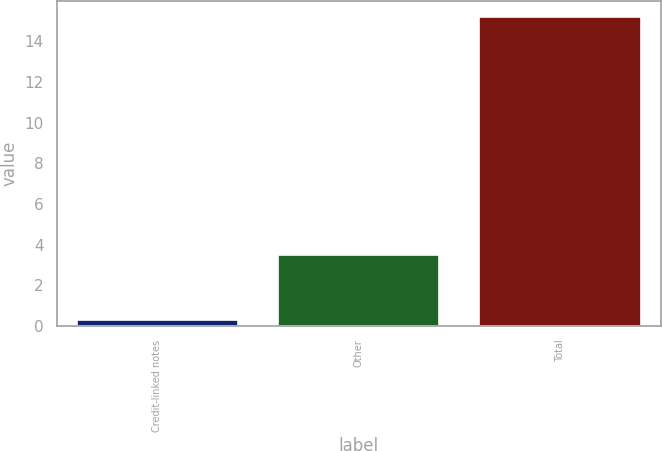<chart> <loc_0><loc_0><loc_500><loc_500><bar_chart><fcel>Credit-linked notes<fcel>Other<fcel>Total<nl><fcel>0.3<fcel>3.5<fcel>15.2<nl></chart> 